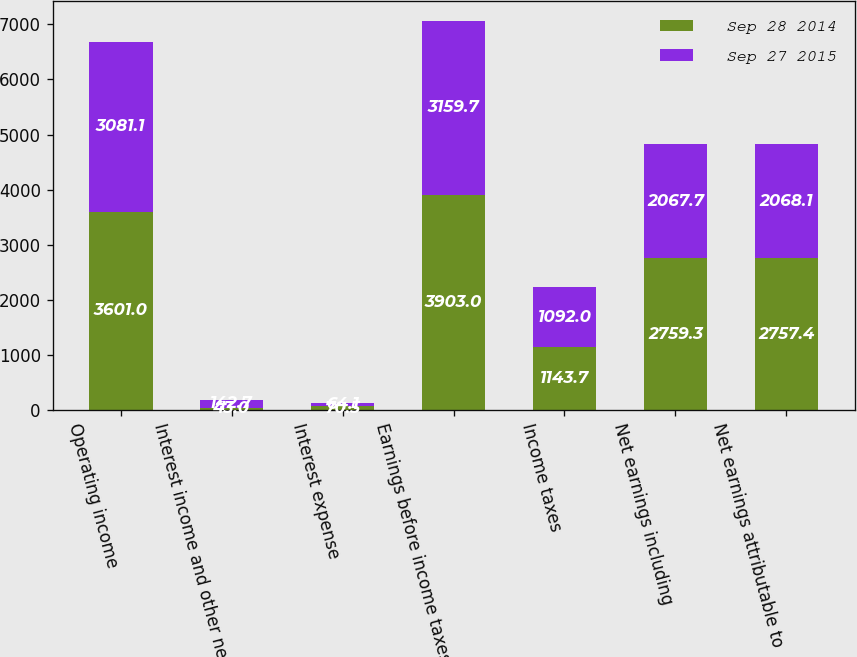<chart> <loc_0><loc_0><loc_500><loc_500><stacked_bar_chart><ecel><fcel>Operating income<fcel>Interest income and other net<fcel>Interest expense<fcel>Earnings before income taxes<fcel>Income taxes<fcel>Net earnings including<fcel>Net earnings attributable to<nl><fcel>Sep 28 2014<fcel>3601<fcel>43<fcel>70.5<fcel>3903<fcel>1143.7<fcel>2759.3<fcel>2757.4<nl><fcel>Sep 27 2015<fcel>3081.1<fcel>142.7<fcel>64.1<fcel>3159.7<fcel>1092<fcel>2067.7<fcel>2068.1<nl></chart> 